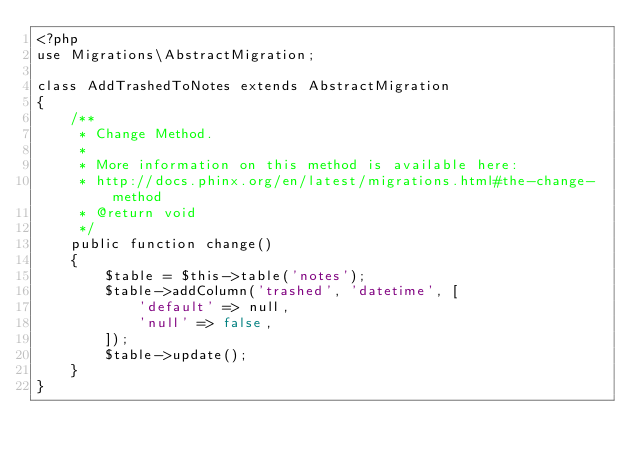<code> <loc_0><loc_0><loc_500><loc_500><_PHP_><?php
use Migrations\AbstractMigration;

class AddTrashedToNotes extends AbstractMigration
{
    /**
     * Change Method.
     *
     * More information on this method is available here:
     * http://docs.phinx.org/en/latest/migrations.html#the-change-method
     * @return void
     */
    public function change()
    {
        $table = $this->table('notes');
        $table->addColumn('trashed', 'datetime', [
            'default' => null,
            'null' => false,
        ]);
        $table->update();
    }
}
</code> 